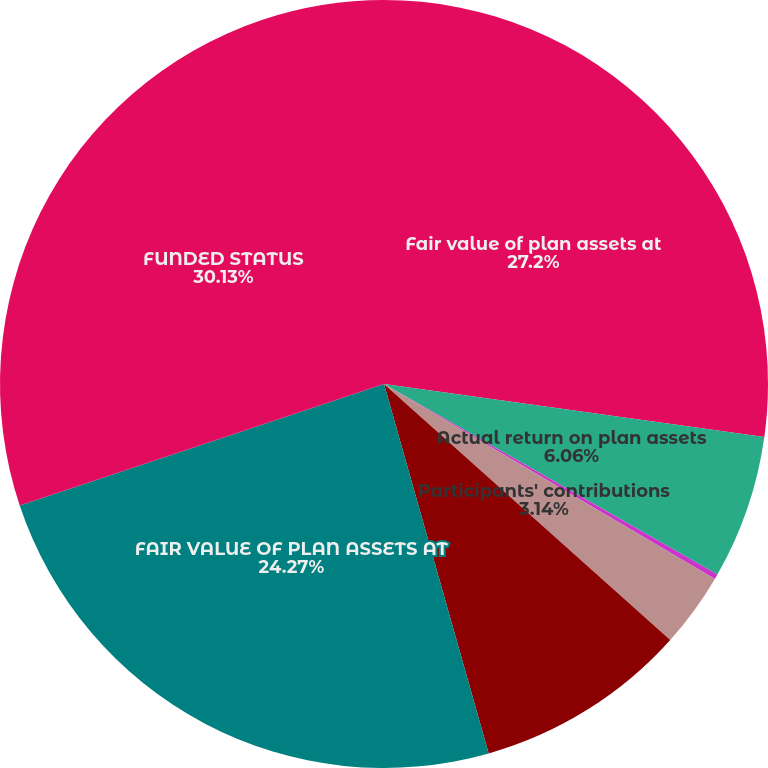Convert chart. <chart><loc_0><loc_0><loc_500><loc_500><pie_chart><fcel>Fair value of plan assets at<fcel>Actual return on plan assets<fcel>Employer contributions<fcel>Participants' contributions<fcel>Benefit payments<fcel>FAIR VALUE OF PLAN ASSETS AT<fcel>FUNDED STATUS<nl><fcel>27.2%<fcel>6.06%<fcel>0.21%<fcel>3.14%<fcel>8.99%<fcel>24.27%<fcel>30.12%<nl></chart> 